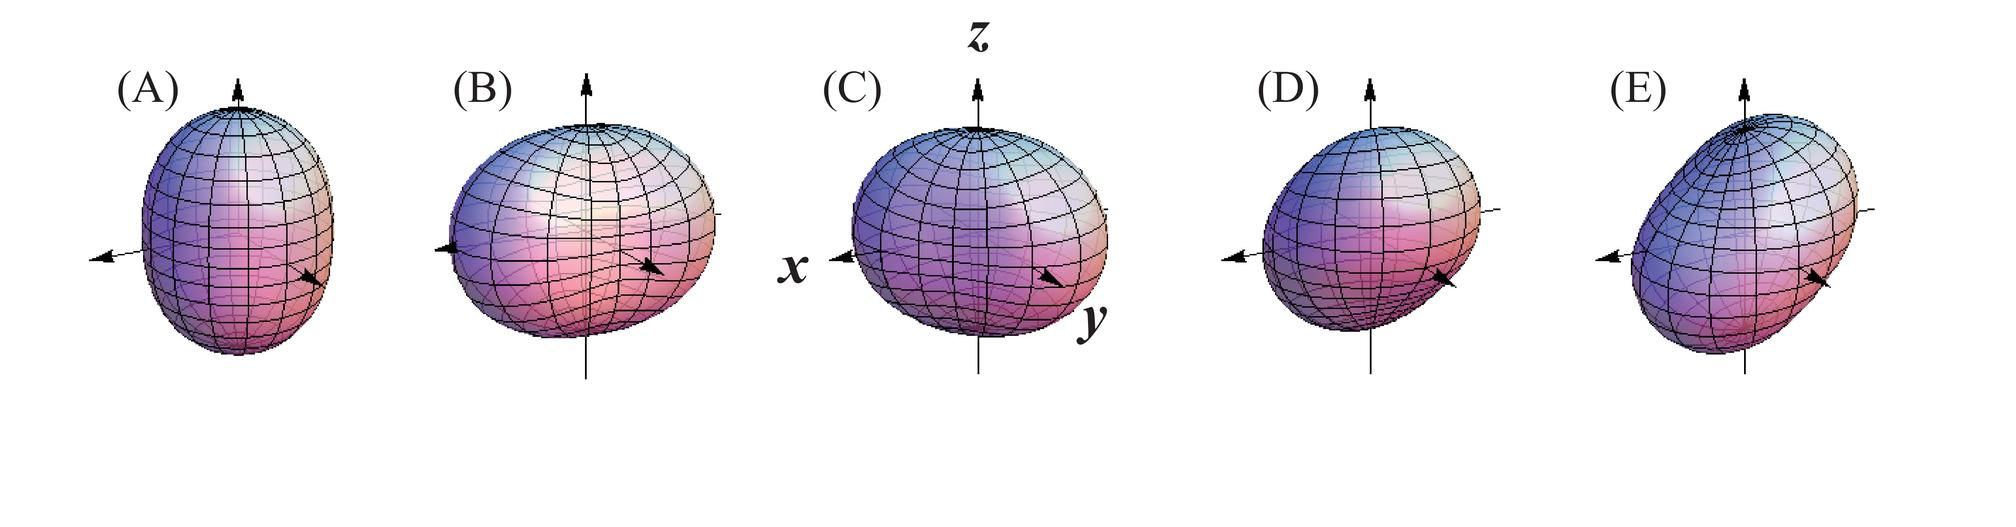What physical property is primarily being demonstrated in these sequences of figures? A) Heat distribution across a surface B) Magnetic field lines around a bar magnet C) Stress distribution within a material under load D) Deformation of a spherical object under different forces The sequence of figures demonstrates a spherical object undergoing changes in shape, which is indicative of deformation due to the application of different forces or pressures, as shown by the arrows indicating direction. Therefore, the correct answer is D) Deformation of a spherical object under different forces. 